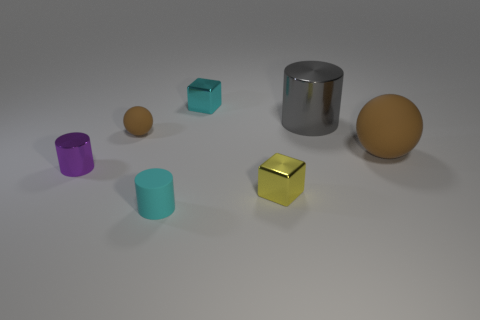What shape is the object that is on the left side of the big matte object and on the right side of the tiny yellow shiny cube? The object situated to the left of the large matte cylinder and to the right of the small yellow glossy cube is indeed itself a cylinder. This particular cylinder has a metallic sheen and appears to be larger than the cube but smaller than the adjacent larger cylinder, suggesting a variation in size among the similarly shaped items. 